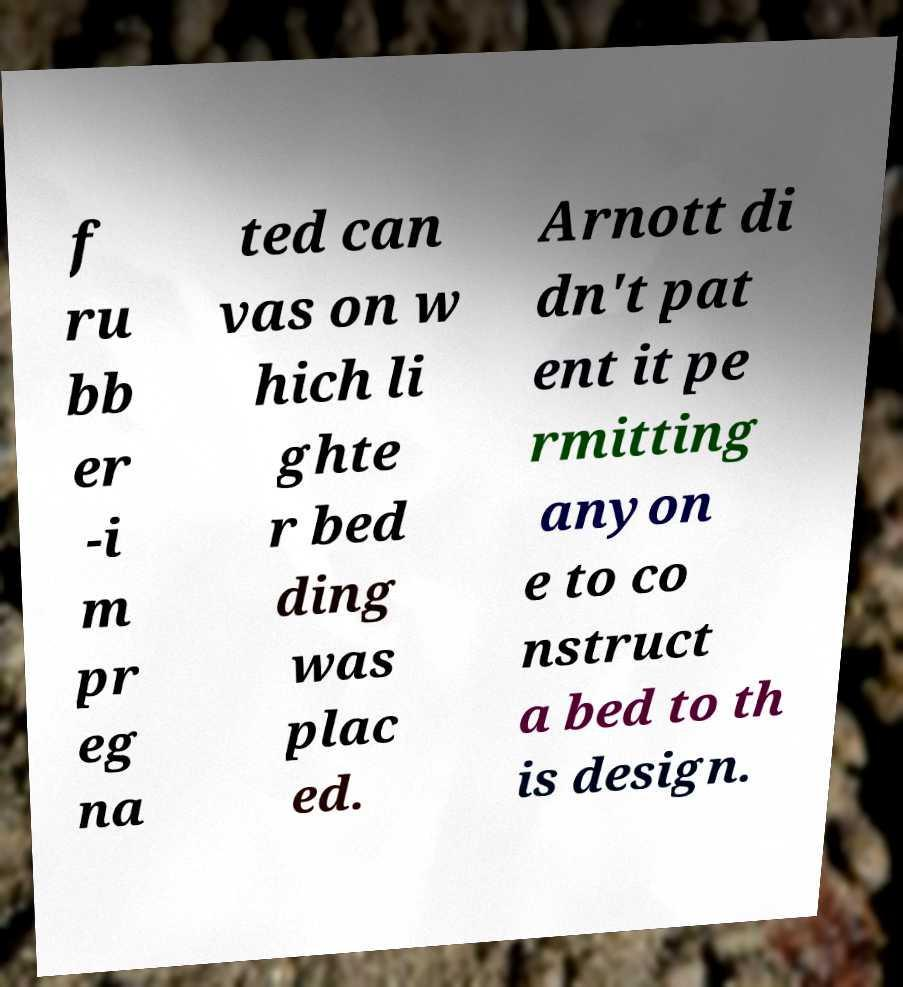Could you extract and type out the text from this image? f ru bb er -i m pr eg na ted can vas on w hich li ghte r bed ding was plac ed. Arnott di dn't pat ent it pe rmitting anyon e to co nstruct a bed to th is design. 